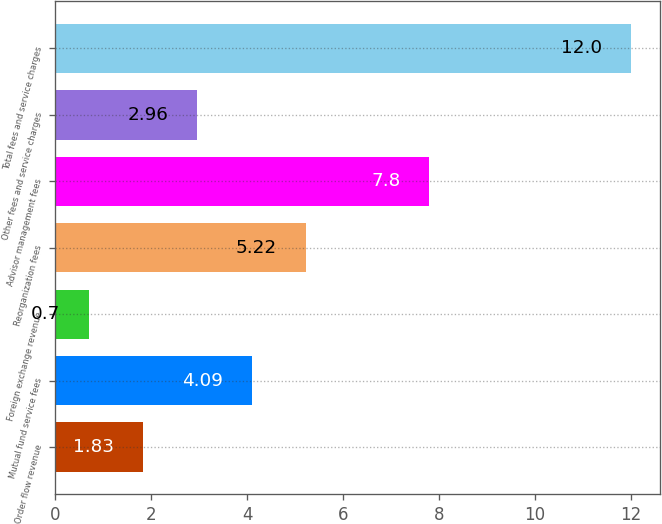Convert chart. <chart><loc_0><loc_0><loc_500><loc_500><bar_chart><fcel>Order flow revenue<fcel>Mutual fund service fees<fcel>Foreign exchange revenue<fcel>Reorganization fees<fcel>Advisor management fees<fcel>Other fees and service charges<fcel>Total fees and service charges<nl><fcel>1.83<fcel>4.09<fcel>0.7<fcel>5.22<fcel>7.8<fcel>2.96<fcel>12<nl></chart> 